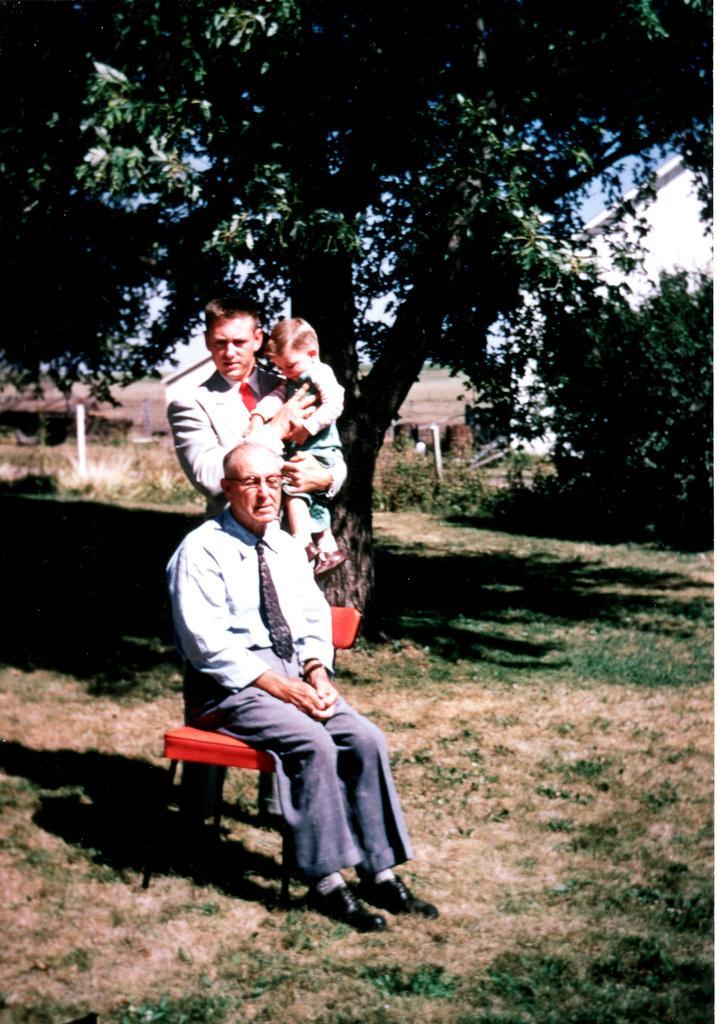How would you summarize this image in a sentence or two? In the image there is a man sitting on the chair and behind the man there is another person standing and holding a baby with his hand, behind them there are trees and around them there is some grass. 